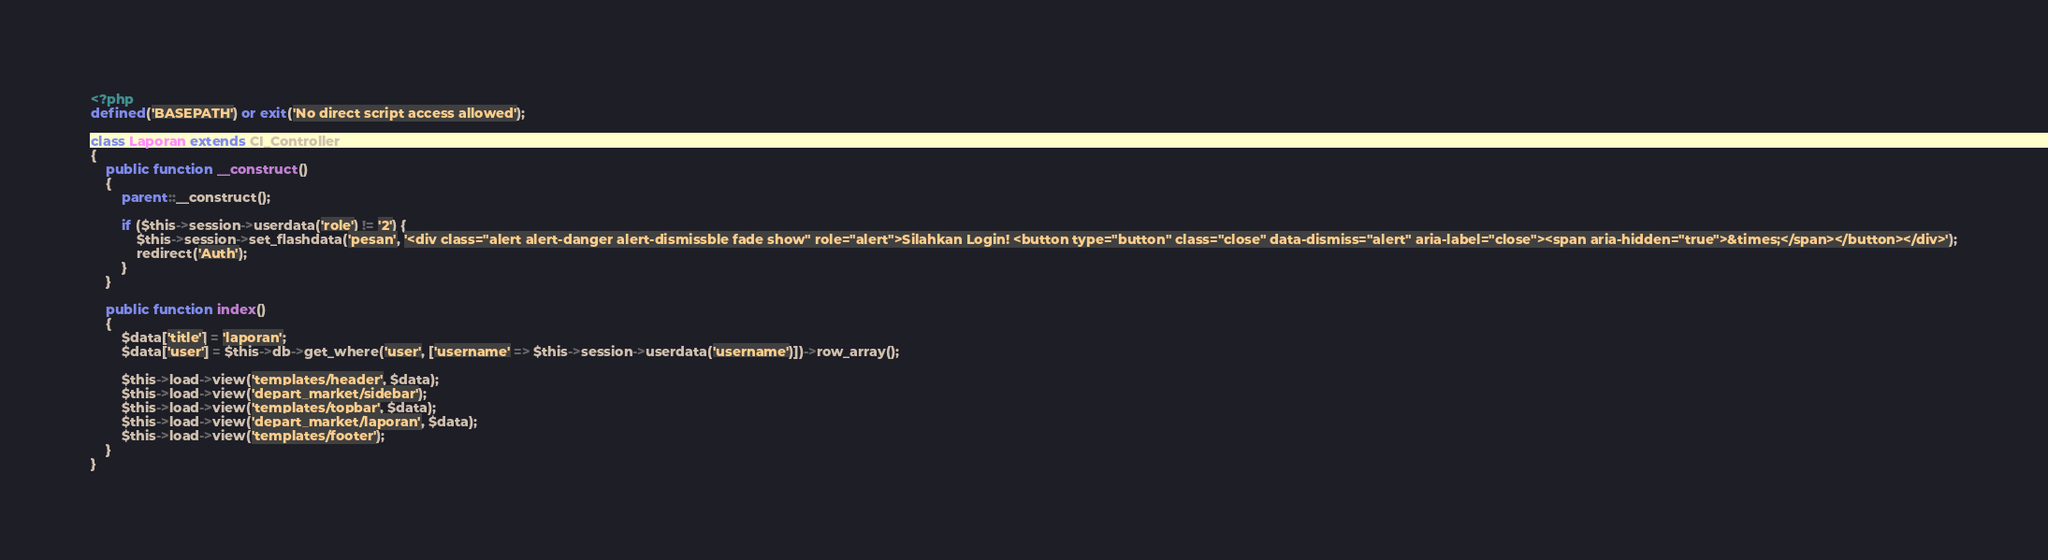Convert code to text. <code><loc_0><loc_0><loc_500><loc_500><_PHP_><?php
defined('BASEPATH') or exit('No direct script access allowed');

class Laporan extends CI_Controller
{
    public function __construct()
    {
        parent::__construct();

        if ($this->session->userdata('role') != '2') {
            $this->session->set_flashdata('pesan', '<div class="alert alert-danger alert-dismissble fade show" role="alert">Silahkan Login! <button type="button" class="close" data-dismiss="alert" aria-label="close"><span aria-hidden="true">&times;</span></button></div>');
            redirect('Auth');
        }
    }

    public function index()
    {
        $data['title'] = 'laporan';
        $data['user'] = $this->db->get_where('user', ['username' => $this->session->userdata('username')])->row_array();

        $this->load->view('templates/header', $data);
        $this->load->view('depart_market/sidebar');
        $this->load->view('templates/topbar', $data);
        $this->load->view('depart_market/laporan', $data);
        $this->load->view('templates/footer');
    }
}
</code> 